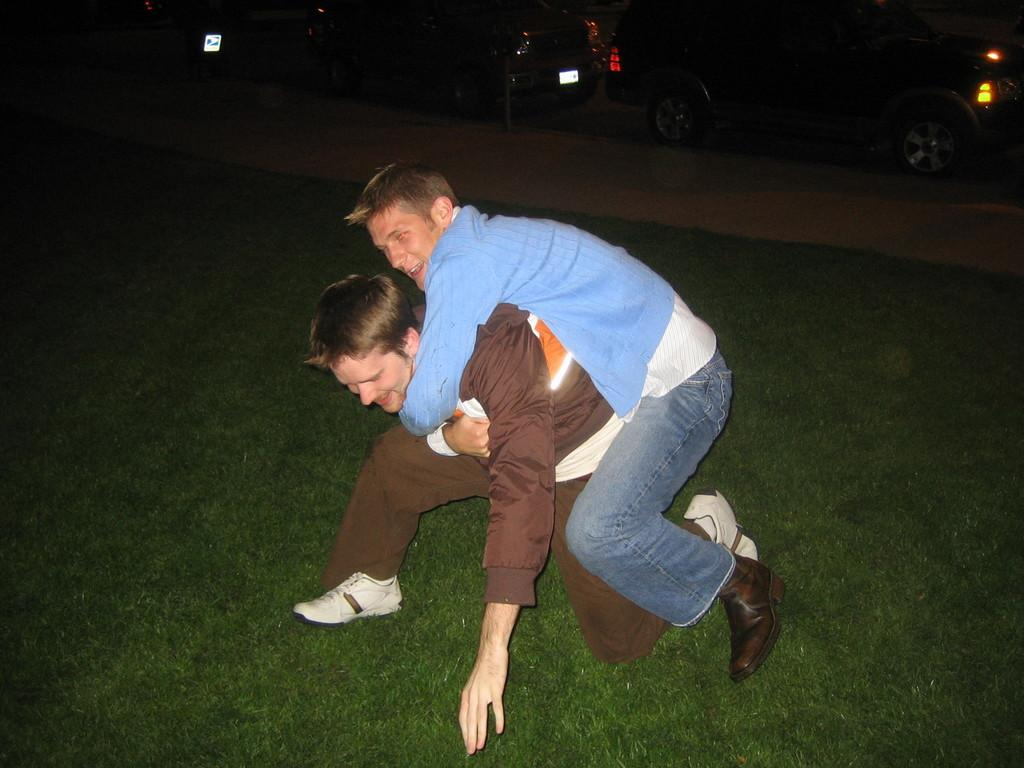Who or what is the main subject in the image? There is a person in the image. What is the setting of the image? The person is on a grassland. What is the person doing in the image? The person is carrying another person on his back. What else can be seen in the image besides the person? There are vehicles visible at the top of the image. Can you describe the location of the vehicles in the image? The vehicles are on a path. What note is the person singing in the image? There is no indication in the image that the person is singing, so it cannot be determined from the picture. 